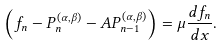Convert formula to latex. <formula><loc_0><loc_0><loc_500><loc_500>\left ( f _ { n } - P _ { n } ^ { ( \alpha , \beta ) } - A P _ { n - 1 } ^ { ( \alpha , \beta ) } \right ) = \mu \frac { d { f _ { n } } } { d { x } } .</formula> 